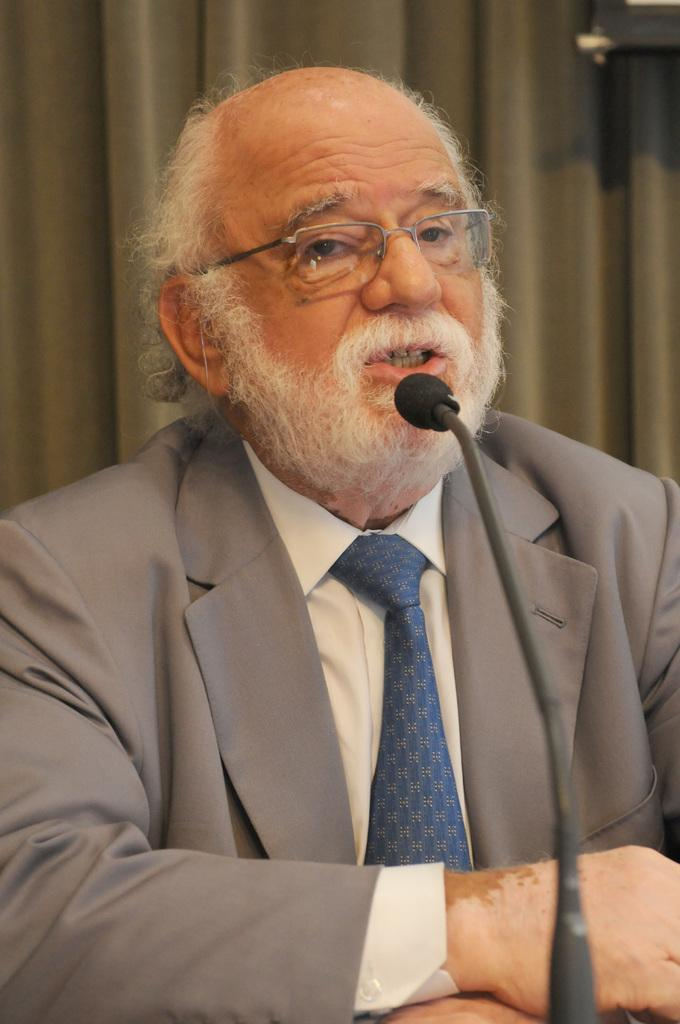Who is present in the image? There is a man in the image. What is the man wearing? The man is wearing formal dress and a blue tie. What accessory is the man wearing? The man is wearing glasses (specs). What object is visible in the image that is related to speaking? There is a microphone (mic) in the image. How many children are visible in the image? There are no children present in the image; it features a man wearing formal dress, a blue tie, and glasses, with a microphone nearby. Can you see a receipt in the image? There is no receipt present in the image. 